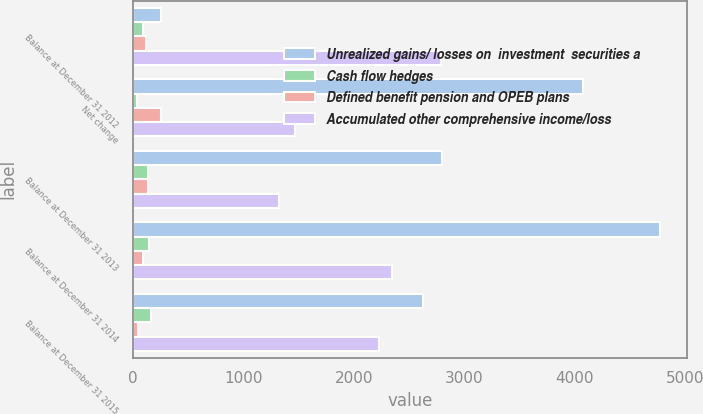Convert chart. <chart><loc_0><loc_0><loc_500><loc_500><stacked_bar_chart><ecel><fcel>Balance at December 31 2012<fcel>Net change<fcel>Balance at December 31 2013<fcel>Balance at December 31 2014<fcel>Balance at December 31 2015<nl><fcel>Unrealized gains/ losses on  investment  securities a<fcel>259<fcel>4070<fcel>2798<fcel>4773<fcel>2629<nl><fcel>Cash flow hedges<fcel>95<fcel>41<fcel>136<fcel>147<fcel>162<nl><fcel>Defined benefit pension and OPEB plans<fcel>120<fcel>259<fcel>139<fcel>95<fcel>44<nl><fcel>Accumulated other comprehensive income/loss<fcel>2791<fcel>1467<fcel>1324<fcel>2342<fcel>2231<nl></chart> 